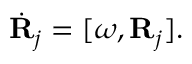<formula> <loc_0><loc_0><loc_500><loc_500>\begin{array} { r } { \dot { R } _ { j } = [ \omega , { R } _ { j } ] . } \end{array}</formula> 